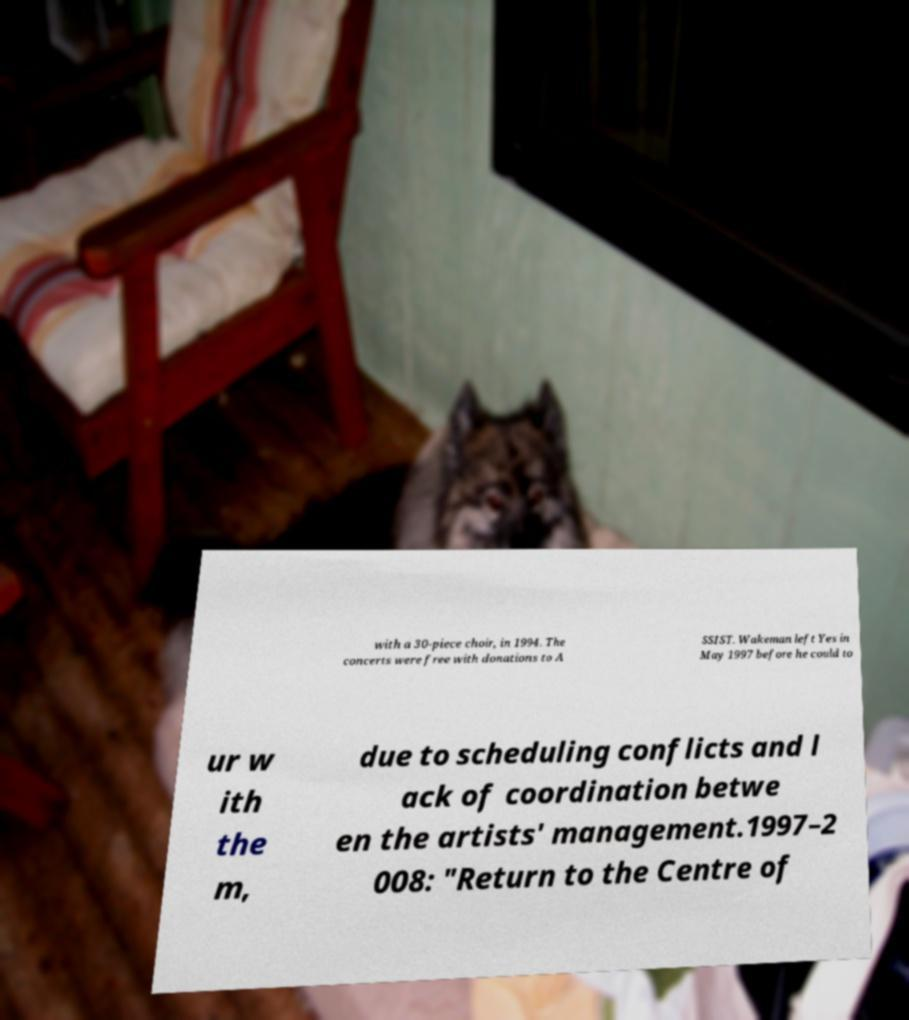Please read and relay the text visible in this image. What does it say? with a 30-piece choir, in 1994. The concerts were free with donations to A SSIST. Wakeman left Yes in May 1997 before he could to ur w ith the m, due to scheduling conflicts and l ack of coordination betwe en the artists' management.1997–2 008: "Return to the Centre of 